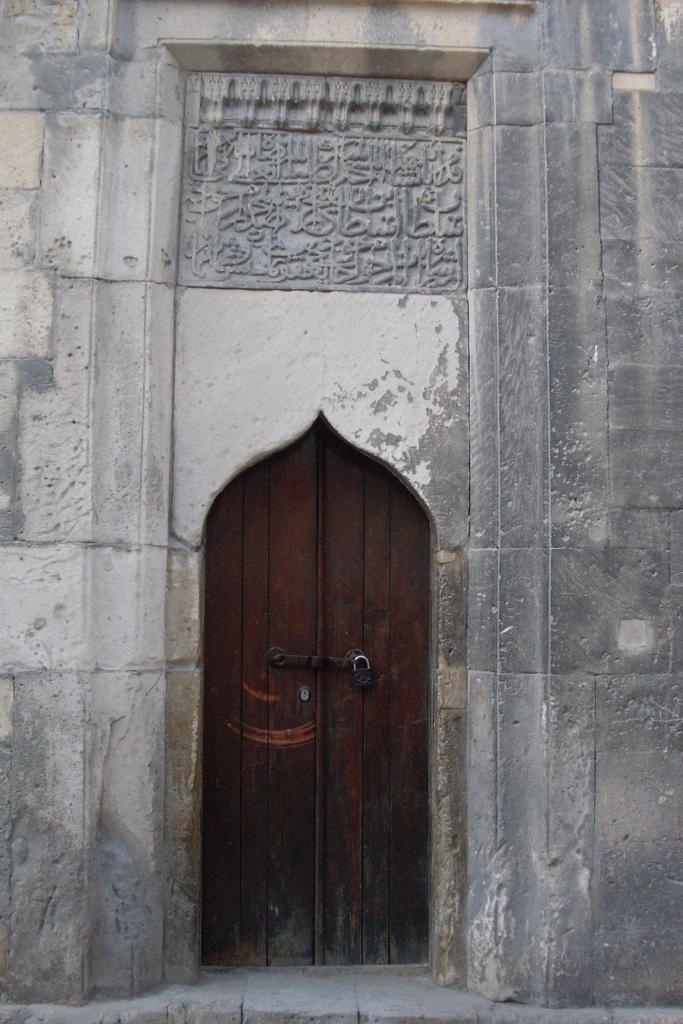What is the main structure in the image? There is a building in the middle of the image. Where is the entrance to the building located? There is a door at the bottom of the building. What feature does the door have? The door has a lock. What type of kettle is boiling oatmelets on the roof of the building in the image? There is no kettle or oatmeal present in the image; the image only shows a building with a door that has a lock. 